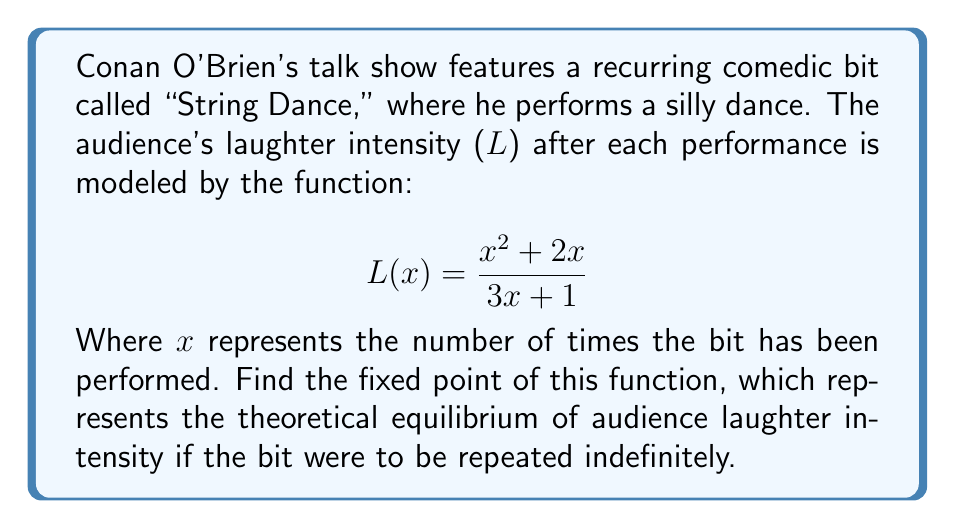Give your solution to this math problem. To find the fixed point of this function, we need to solve the equation $L(x) = x$. This means:

$$\frac{x^2 + 2x}{3x + 1} = x$$

Let's solve this step-by-step:

1) Multiply both sides by $(3x + 1)$:
   $x^2 + 2x = x(3x + 1)$

2) Expand the right side:
   $x^2 + 2x = 3x^2 + x$

3) Subtract $x^2$ and $x$ from both sides:
   $x = 2x^2$

4) Subtract $x$ from both sides:
   $0 = 2x^2 - x$

5) Factor out $x$:
   $0 = x(2x - 1)$

6) Solve for $x$:
   $x = 0$ or $2x - 1 = 0$
   $x = 0$ or $x = \frac{1}{2}$

7) Since laughter intensity can't be 0 in this context, we discard that solution.

Therefore, the fixed point is $x = \frac{1}{2}$.

To verify, we can plug this back into the original function:

$$L(\frac{1}{2}) = \frac{(\frac{1}{2})^2 + 2(\frac{1}{2})}{3(\frac{1}{2}) + 1} = \frac{\frac{1}{4} + 1}{\frac{3}{2} + 1} = \frac{\frac{5}{4}}{\frac{5}{2}} = \frac{1}{2}$$

This confirms that $\frac{1}{2}$ is indeed the fixed point.
Answer: The fixed point of the function is $\frac{1}{2}$. 